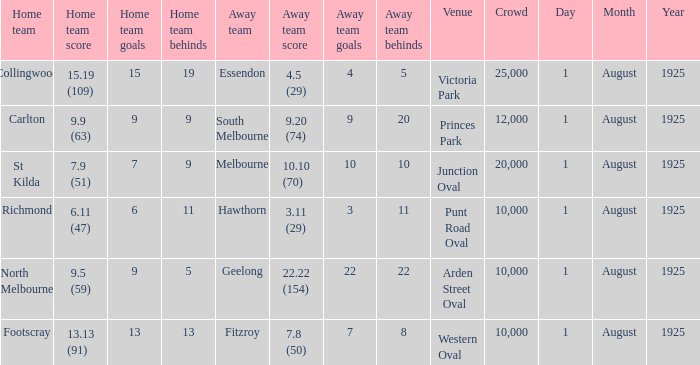At the match where the away team scored 4.5 (29), what was the crowd size? 1.0. 